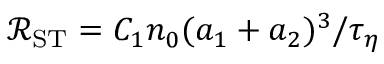<formula> <loc_0><loc_0><loc_500><loc_500>\ m a t h s c r { R } _ { S T } = C _ { 1 } n _ { 0 } ( a _ { 1 } + a _ { 2 } ) ^ { 3 } / \tau _ { \eta }</formula> 